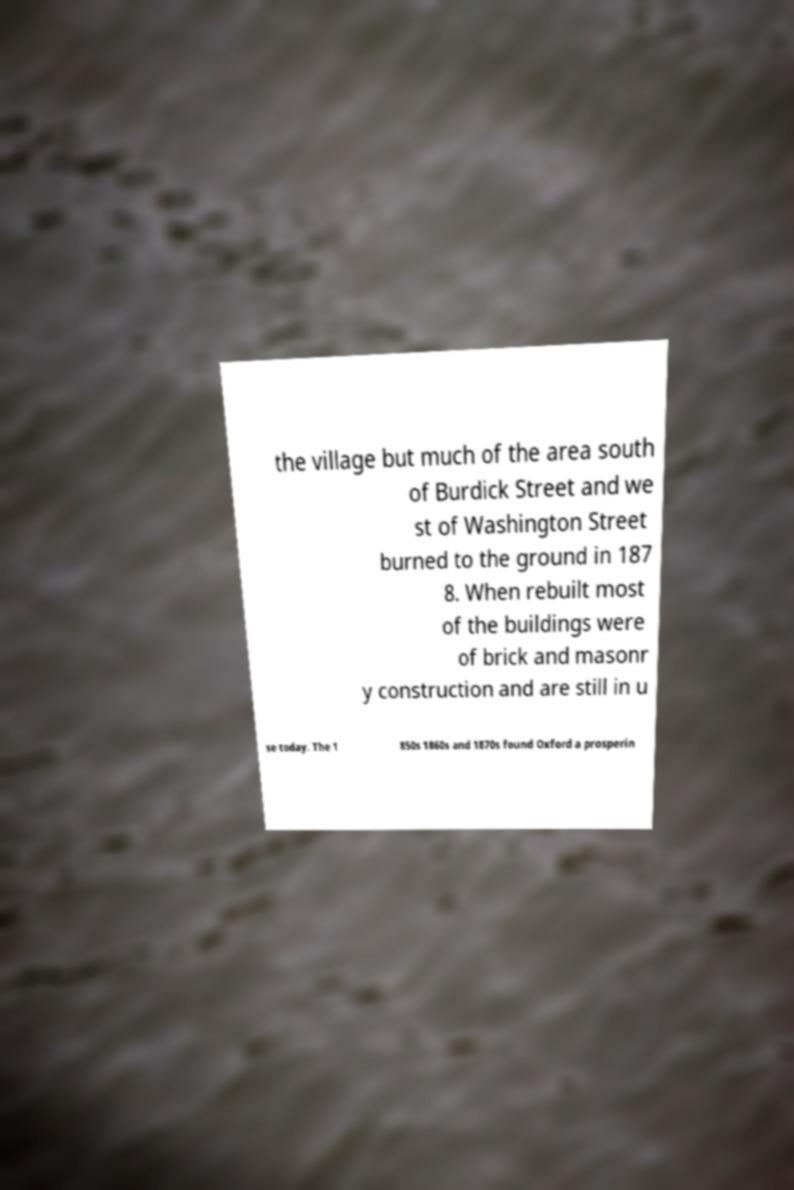There's text embedded in this image that I need extracted. Can you transcribe it verbatim? the village but much of the area south of Burdick Street and we st of Washington Street burned to the ground in 187 8. When rebuilt most of the buildings were of brick and masonr y construction and are still in u se today. The 1 850s 1860s and 1870s found Oxford a prosperin 